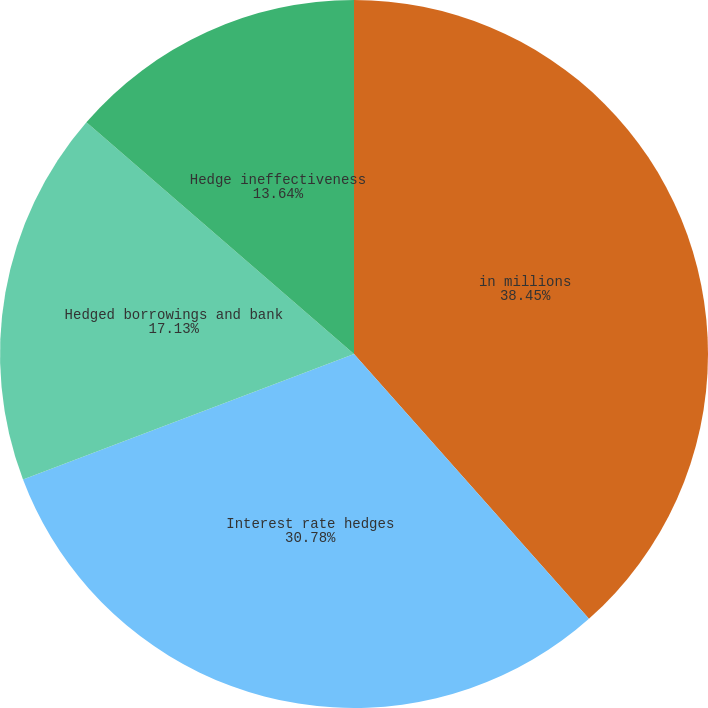Convert chart. <chart><loc_0><loc_0><loc_500><loc_500><pie_chart><fcel>in millions<fcel>Interest rate hedges<fcel>Hedged borrowings and bank<fcel>Hedge ineffectiveness<nl><fcel>38.45%<fcel>30.78%<fcel>17.13%<fcel>13.64%<nl></chart> 